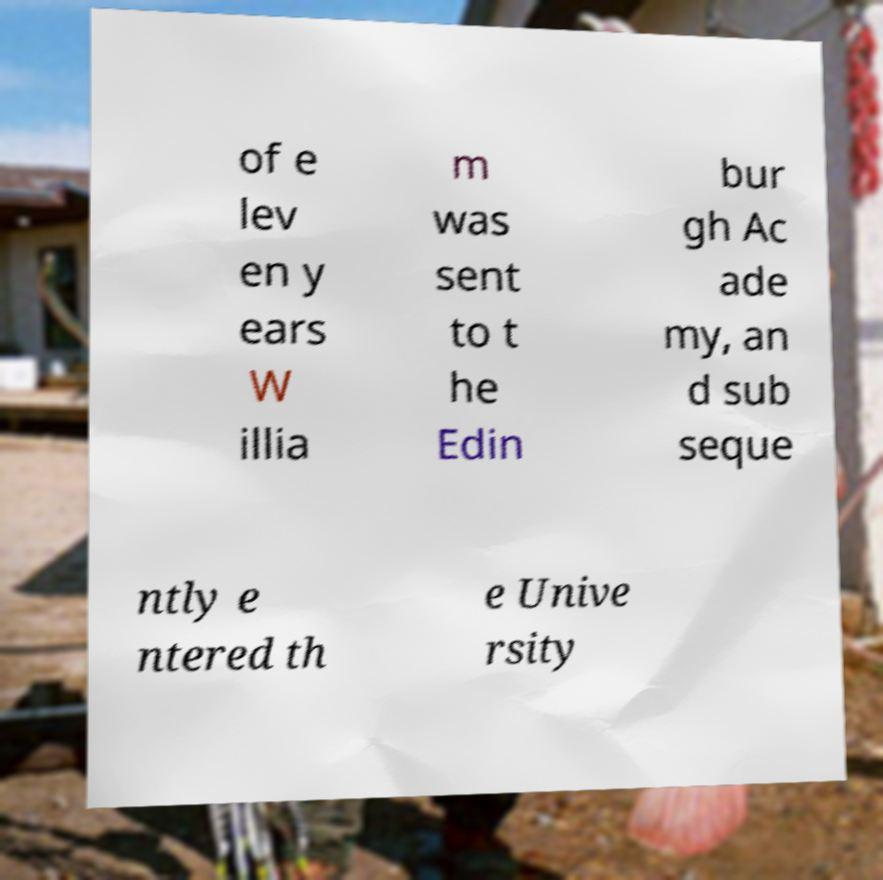Please identify and transcribe the text found in this image. of e lev en y ears W illia m was sent to t he Edin bur gh Ac ade my, an d sub seque ntly e ntered th e Unive rsity 